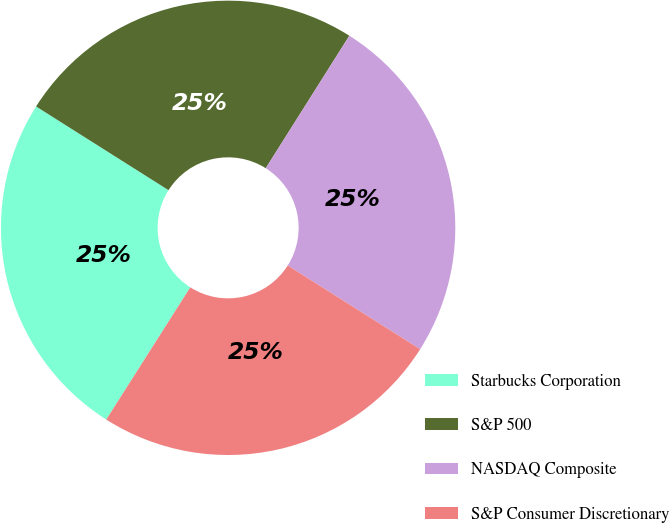<chart> <loc_0><loc_0><loc_500><loc_500><pie_chart><fcel>Starbucks Corporation<fcel>S&P 500<fcel>NASDAQ Composite<fcel>S&P Consumer Discretionary<nl><fcel>24.96%<fcel>24.99%<fcel>25.01%<fcel>25.04%<nl></chart> 